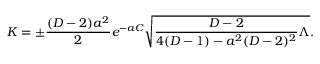<formula> <loc_0><loc_0><loc_500><loc_500>K = \pm { \frac { ( D - 2 ) a ^ { 2 } } { 2 } } e ^ { - a C } \sqrt { { \frac { D - 2 } { 4 ( D - 1 ) - a ^ { 2 } ( D - 2 ) ^ { 2 } } } \Lambda } .</formula> 